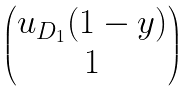<formula> <loc_0><loc_0><loc_500><loc_500>\begin{pmatrix} u _ { D _ { 1 } } ( 1 - y ) \\ 1 \end{pmatrix}</formula> 